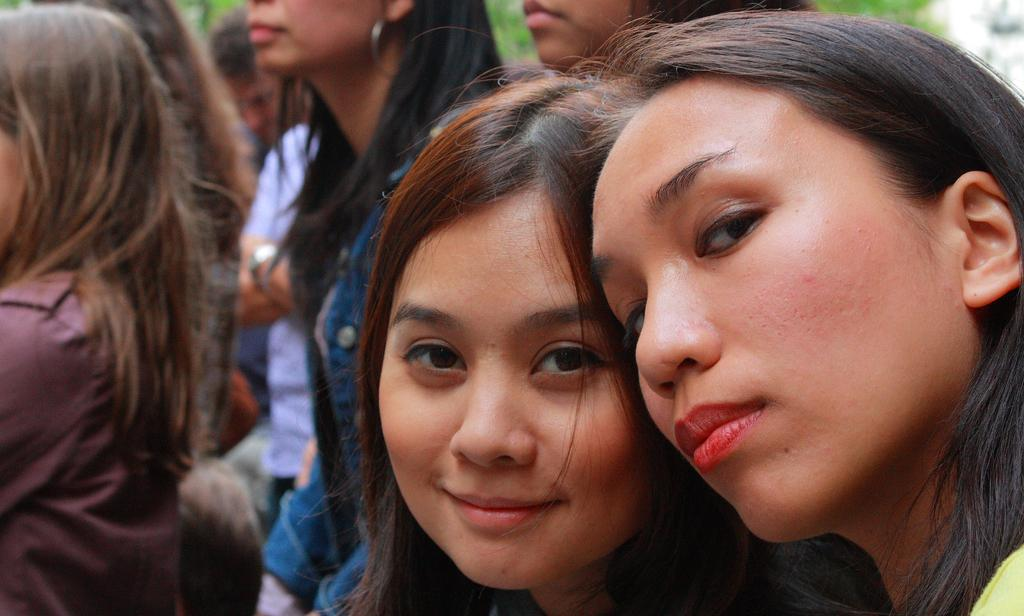How many people are in the image? There are girls in the image. What are the girls doing in the image? The girls are standing. What type of pig is comfortably sitting next to the girls in the image? There is no pig present in the image; only girls are visible. 